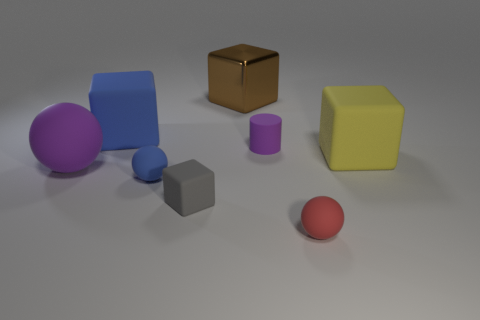What is the shape of the blue thing that is the same size as the red sphere?
Offer a terse response. Sphere. Are there any yellow rubber objects of the same shape as the big blue object?
Keep it short and to the point. Yes. How many brown things have the same material as the purple cylinder?
Give a very brief answer. 0. Is the ball in front of the gray cube made of the same material as the brown block?
Make the answer very short. No. Is the number of balls that are right of the small rubber cylinder greater than the number of shiny objects that are on the right side of the big brown block?
Offer a very short reply. Yes. There is a brown object that is the same size as the blue rubber block; what is its material?
Offer a very short reply. Metal. What number of other things are the same material as the brown object?
Provide a succinct answer. 0. There is a big thing to the right of the large metal block; does it have the same shape as the blue thing that is behind the large purple matte sphere?
Make the answer very short. Yes. How many other objects are the same color as the tiny cylinder?
Make the answer very short. 1. Does the cube that is left of the small blue thing have the same material as the purple thing right of the big sphere?
Keep it short and to the point. Yes. 